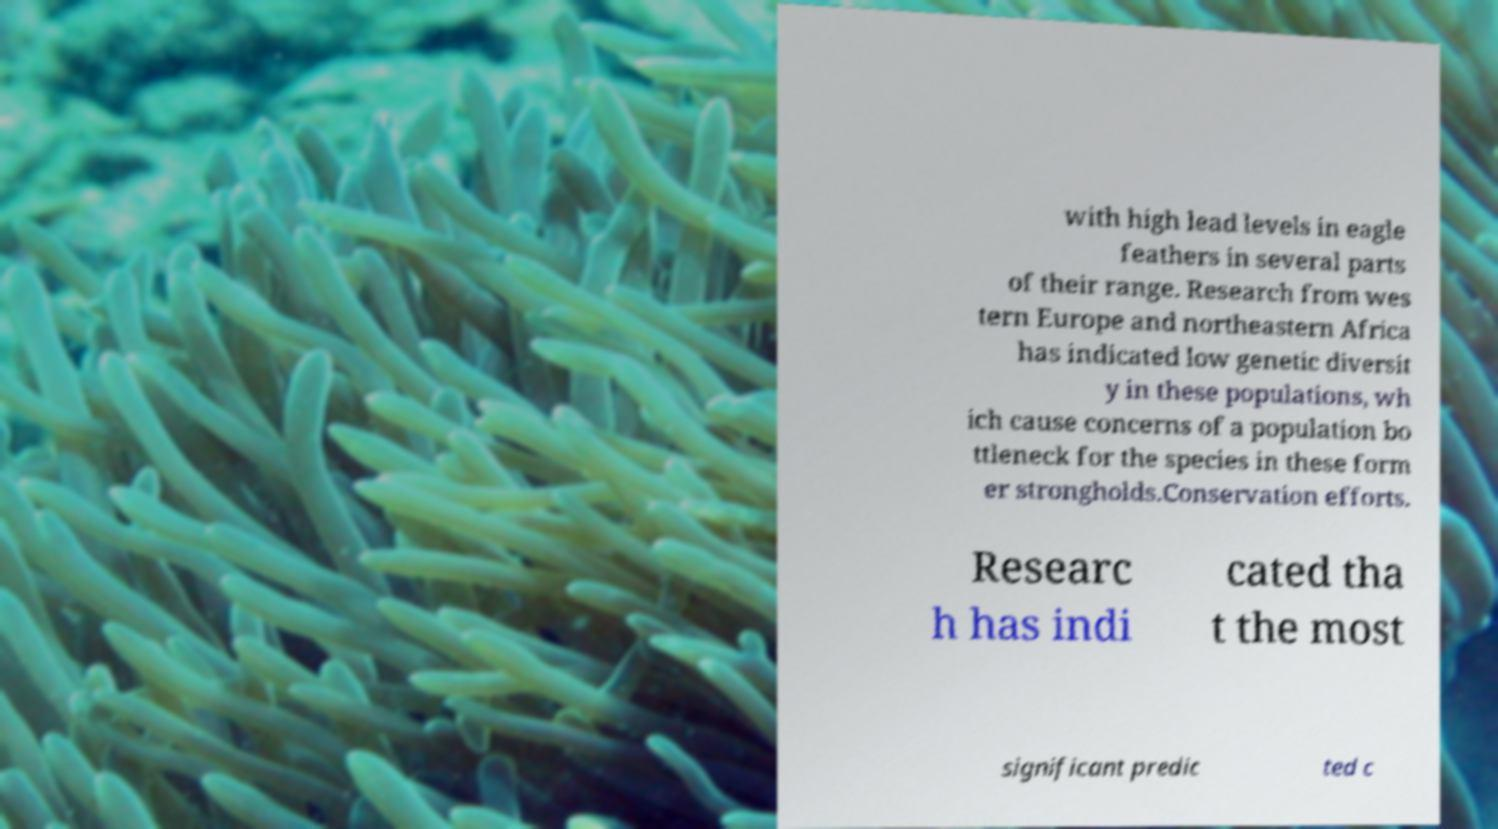Could you extract and type out the text from this image? with high lead levels in eagle feathers in several parts of their range. Research from wes tern Europe and northeastern Africa has indicated low genetic diversit y in these populations, wh ich cause concerns of a population bo ttleneck for the species in these form er strongholds.Conservation efforts. Researc h has indi cated tha t the most significant predic ted c 